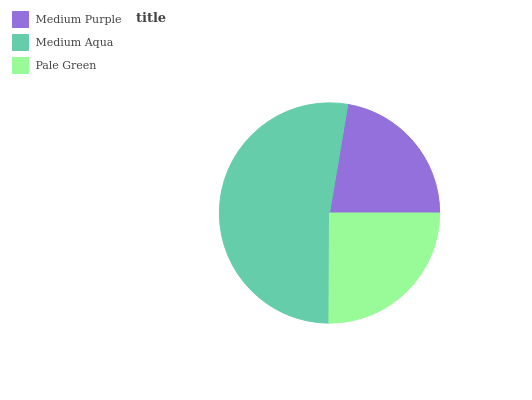Is Medium Purple the minimum?
Answer yes or no. Yes. Is Medium Aqua the maximum?
Answer yes or no. Yes. Is Pale Green the minimum?
Answer yes or no. No. Is Pale Green the maximum?
Answer yes or no. No. Is Medium Aqua greater than Pale Green?
Answer yes or no. Yes. Is Pale Green less than Medium Aqua?
Answer yes or no. Yes. Is Pale Green greater than Medium Aqua?
Answer yes or no. No. Is Medium Aqua less than Pale Green?
Answer yes or no. No. Is Pale Green the high median?
Answer yes or no. Yes. Is Pale Green the low median?
Answer yes or no. Yes. Is Medium Purple the high median?
Answer yes or no. No. Is Medium Aqua the low median?
Answer yes or no. No. 